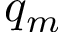Convert formula to latex. <formula><loc_0><loc_0><loc_500><loc_500>q _ { m }</formula> 